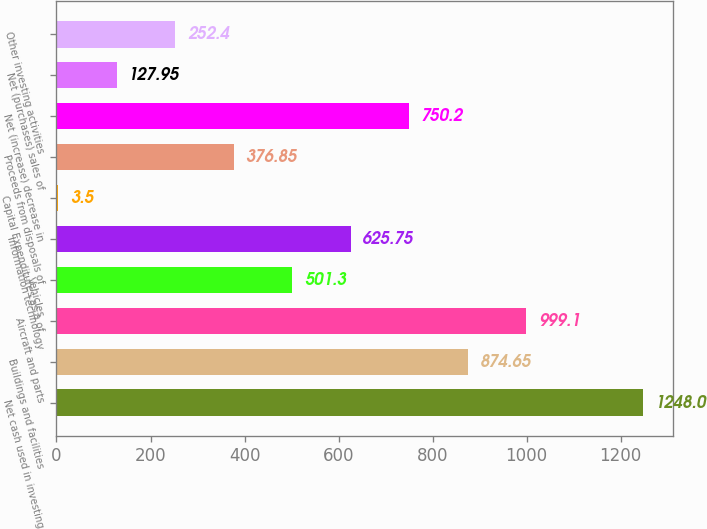<chart> <loc_0><loc_0><loc_500><loc_500><bar_chart><fcel>Net cash used in investing<fcel>Buildings and facilities<fcel>Aircraft and parts<fcel>Vehicles<fcel>Information technology<fcel>Capital Expenditures as a of<fcel>Proceeds from disposals of<fcel>Net (increase) decrease in<fcel>Net (purchases) sales of<fcel>Other investing activities<nl><fcel>1248<fcel>874.65<fcel>999.1<fcel>501.3<fcel>625.75<fcel>3.5<fcel>376.85<fcel>750.2<fcel>127.95<fcel>252.4<nl></chart> 